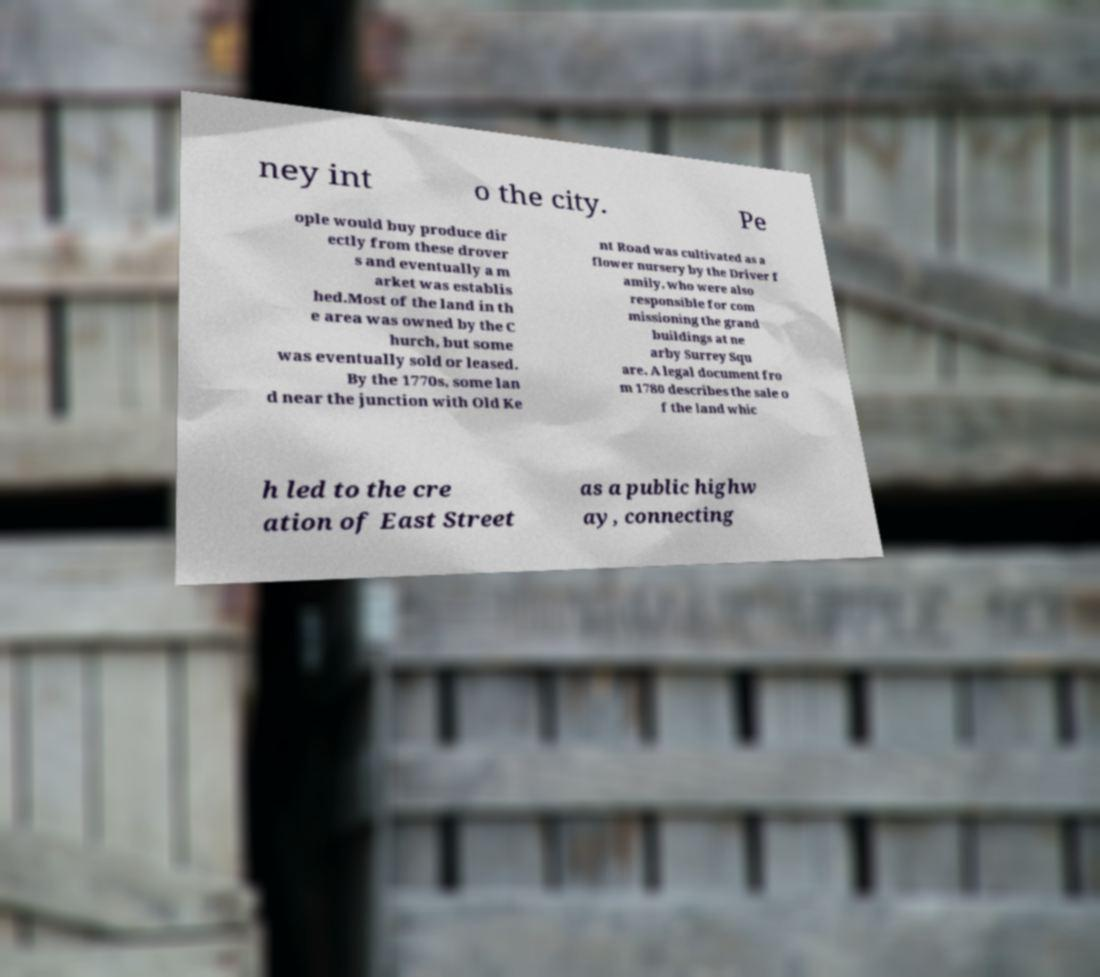Could you extract and type out the text from this image? ney int o the city. Pe ople would buy produce dir ectly from these drover s and eventually a m arket was establis hed.Most of the land in th e area was owned by the C hurch, but some was eventually sold or leased. By the 1770s, some lan d near the junction with Old Ke nt Road was cultivated as a flower nursery by the Driver f amily, who were also responsible for com missioning the grand buildings at ne arby Surrey Squ are. A legal document fro m 1780 describes the sale o f the land whic h led to the cre ation of East Street as a public highw ay, connecting 